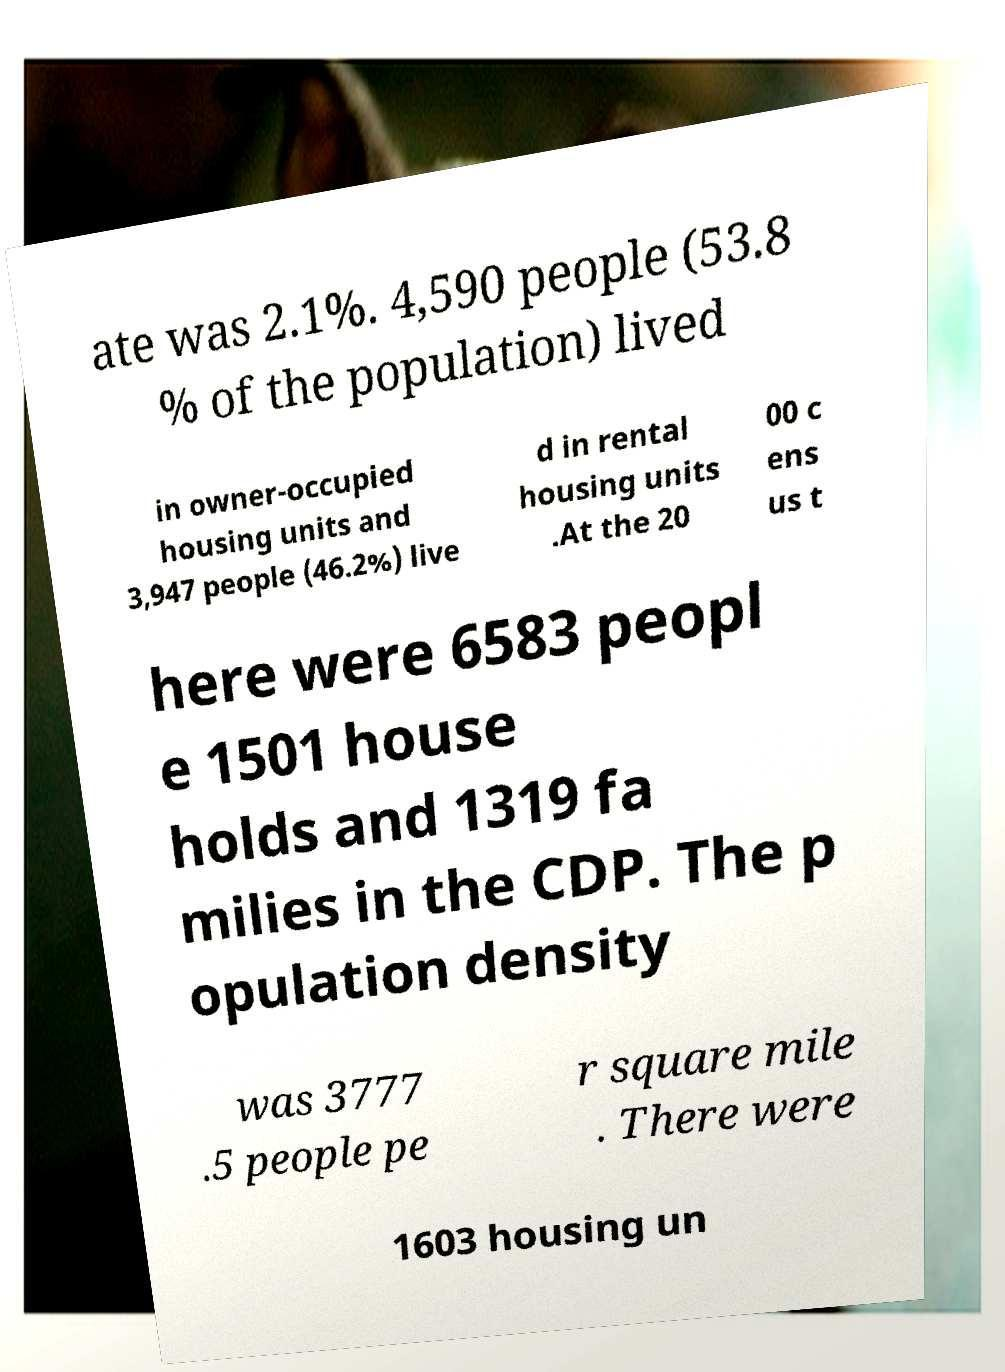Could you extract and type out the text from this image? ate was 2.1%. 4,590 people (53.8 % of the population) lived in owner-occupied housing units and 3,947 people (46.2%) live d in rental housing units .At the 20 00 c ens us t here were 6583 peopl e 1501 house holds and 1319 fa milies in the CDP. The p opulation density was 3777 .5 people pe r square mile . There were 1603 housing un 